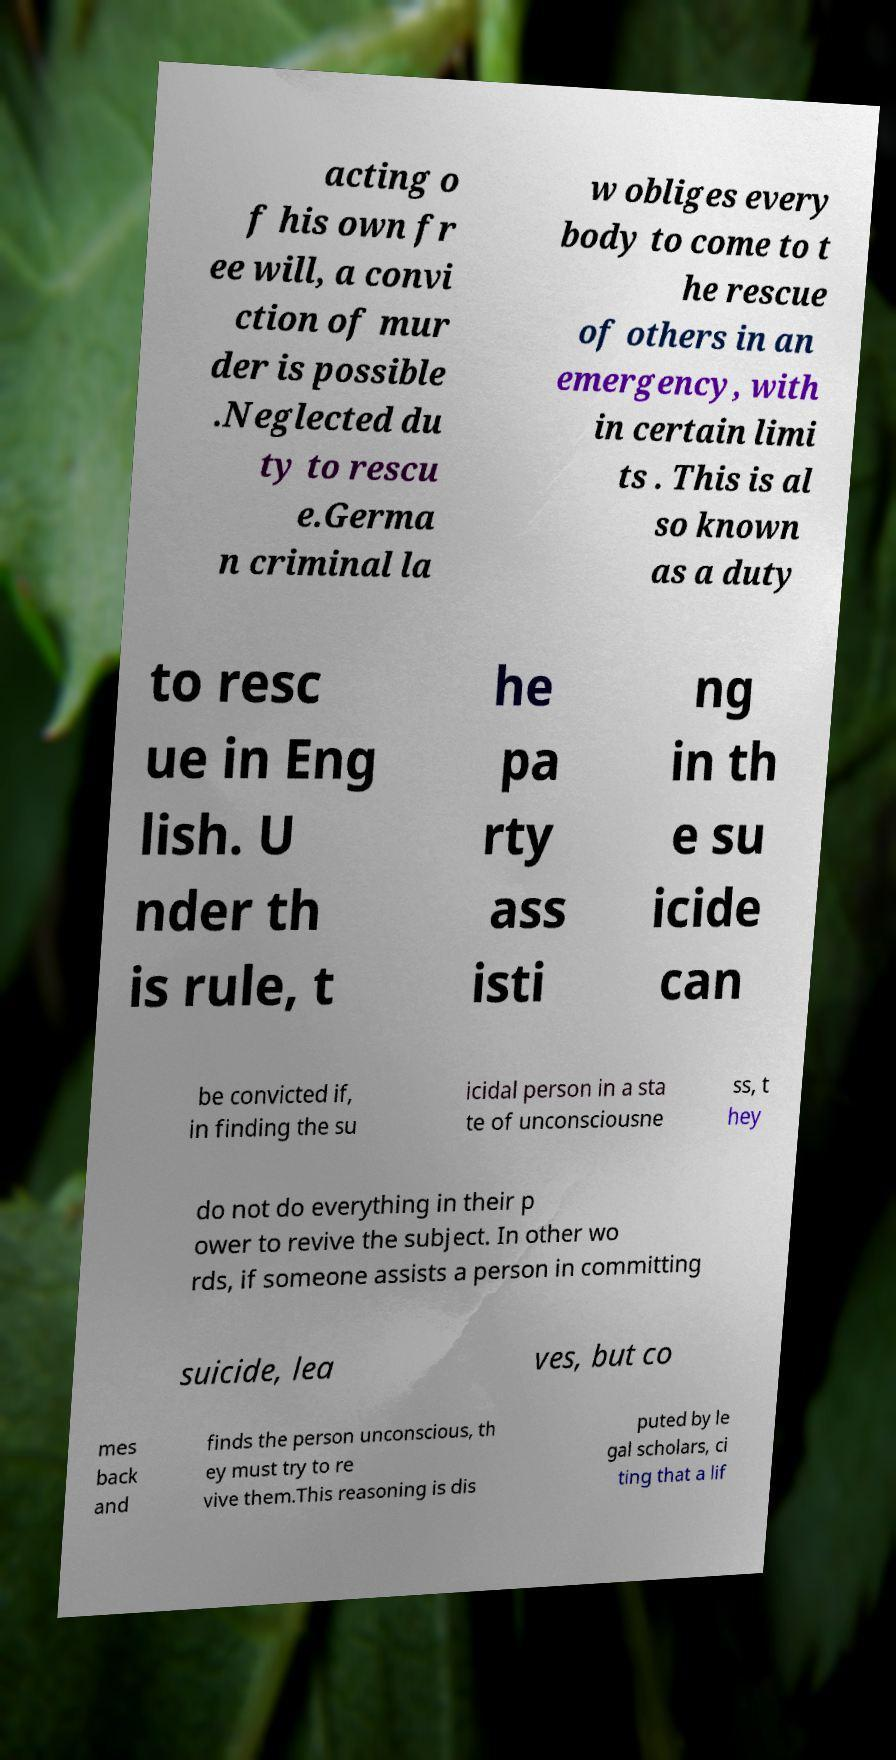What messages or text are displayed in this image? I need them in a readable, typed format. acting o f his own fr ee will, a convi ction of mur der is possible .Neglected du ty to rescu e.Germa n criminal la w obliges every body to come to t he rescue of others in an emergency, with in certain limi ts . This is al so known as a duty to resc ue in Eng lish. U nder th is rule, t he pa rty ass isti ng in th e su icide can be convicted if, in finding the su icidal person in a sta te of unconsciousne ss, t hey do not do everything in their p ower to revive the subject. In other wo rds, if someone assists a person in committing suicide, lea ves, but co mes back and finds the person unconscious, th ey must try to re vive them.This reasoning is dis puted by le gal scholars, ci ting that a lif 